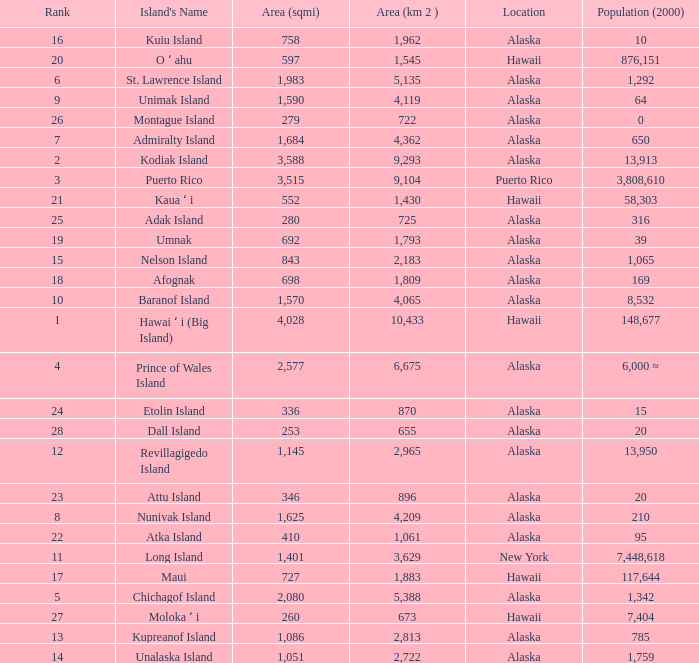What is the largest rank with 2,080 area? 5.0. 